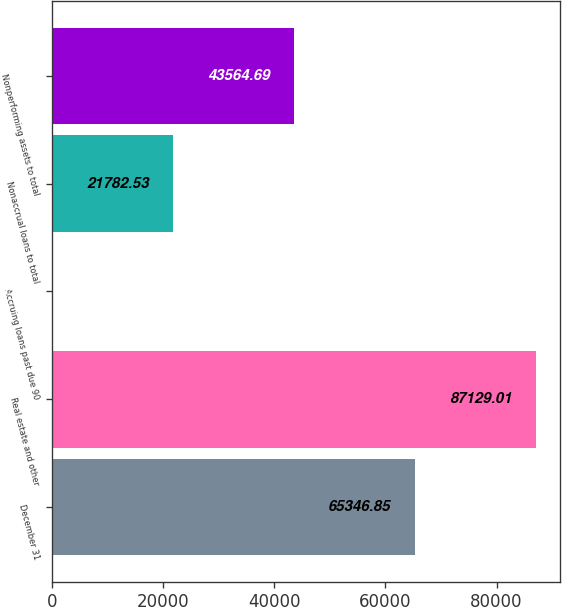Convert chart to OTSL. <chart><loc_0><loc_0><loc_500><loc_500><bar_chart><fcel>December 31<fcel>Real estate and other<fcel>Accruing loans past due 90<fcel>Nonaccrual loans to total<fcel>Nonperforming assets to total<nl><fcel>65346.8<fcel>87129<fcel>0.37<fcel>21782.5<fcel>43564.7<nl></chart> 